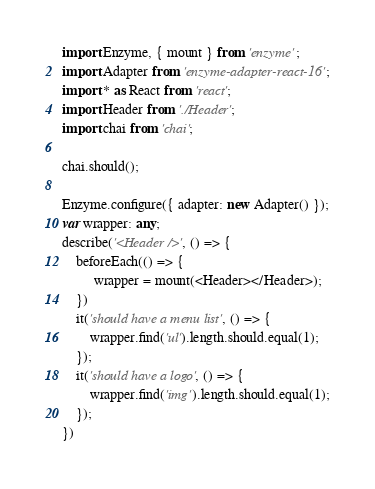<code> <loc_0><loc_0><loc_500><loc_500><_TypeScript_>import Enzyme, { mount } from 'enzyme';
import Adapter from 'enzyme-adapter-react-16';
import * as React from 'react';
import Header from './Header';
import chai from 'chai';

chai.should();

Enzyme.configure({ adapter: new Adapter() });
var wrapper: any; 
describe('<Header />', () => {
    beforeEach(() => {
         wrapper = mount(<Header></Header>);
    })
    it('should have a menu list', () => {
        wrapper.find('ul').length.should.equal(1);
    });
    it('should have a logo', () => {
        wrapper.find('img').length.should.equal(1);
    });
})</code> 